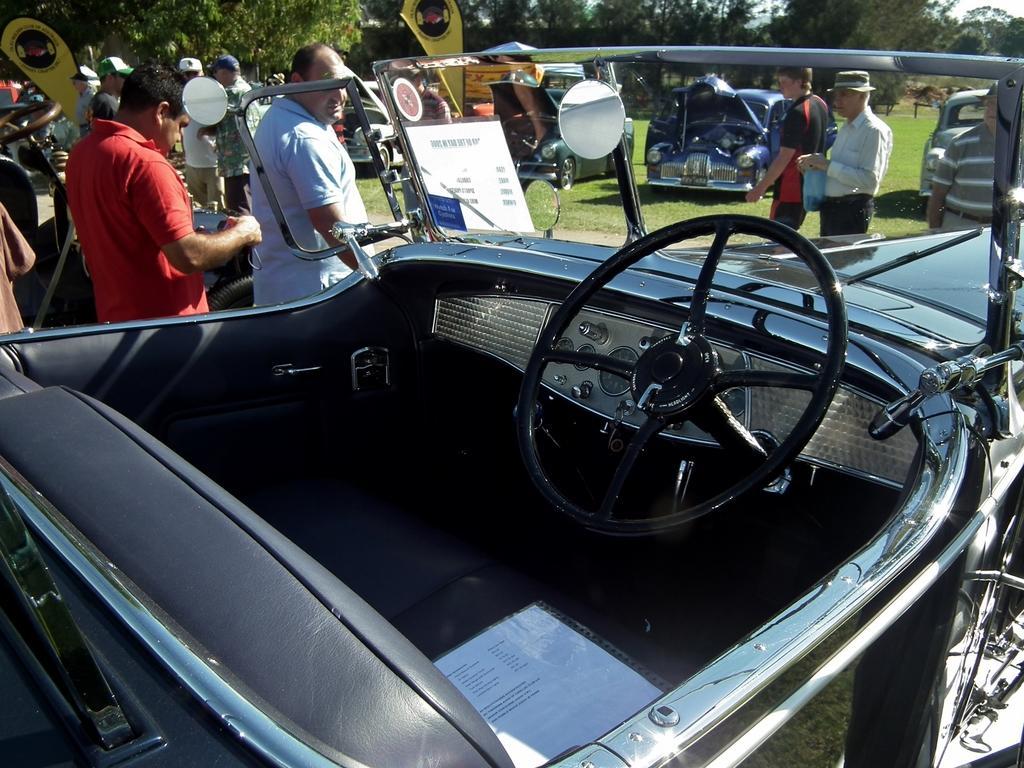How would you summarize this image in a sentence or two? In this image I can see the inner part of the vehicle and I can also see the steering. In the background I can see the group of people standing, few vehicles, trees in green color and the sky is in white color. 